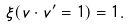<formula> <loc_0><loc_0><loc_500><loc_500>\xi ( v \cdot v ^ { \prime } = 1 ) = 1 .</formula> 